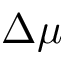<formula> <loc_0><loc_0><loc_500><loc_500>\Delta \mu</formula> 